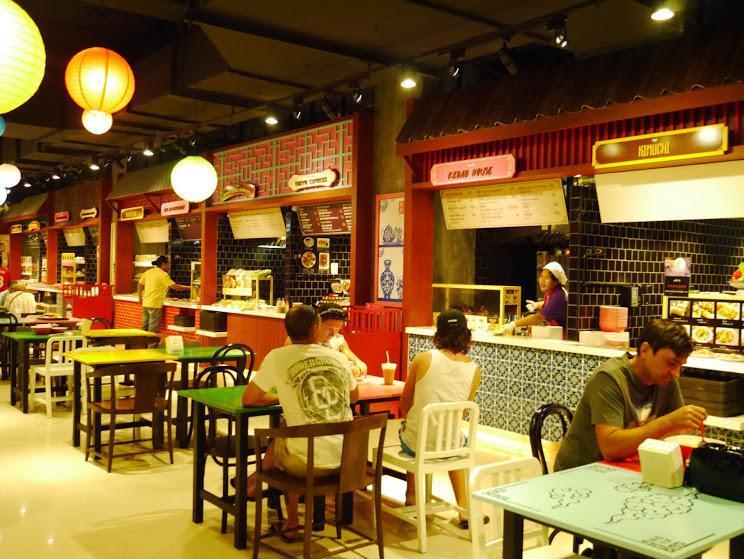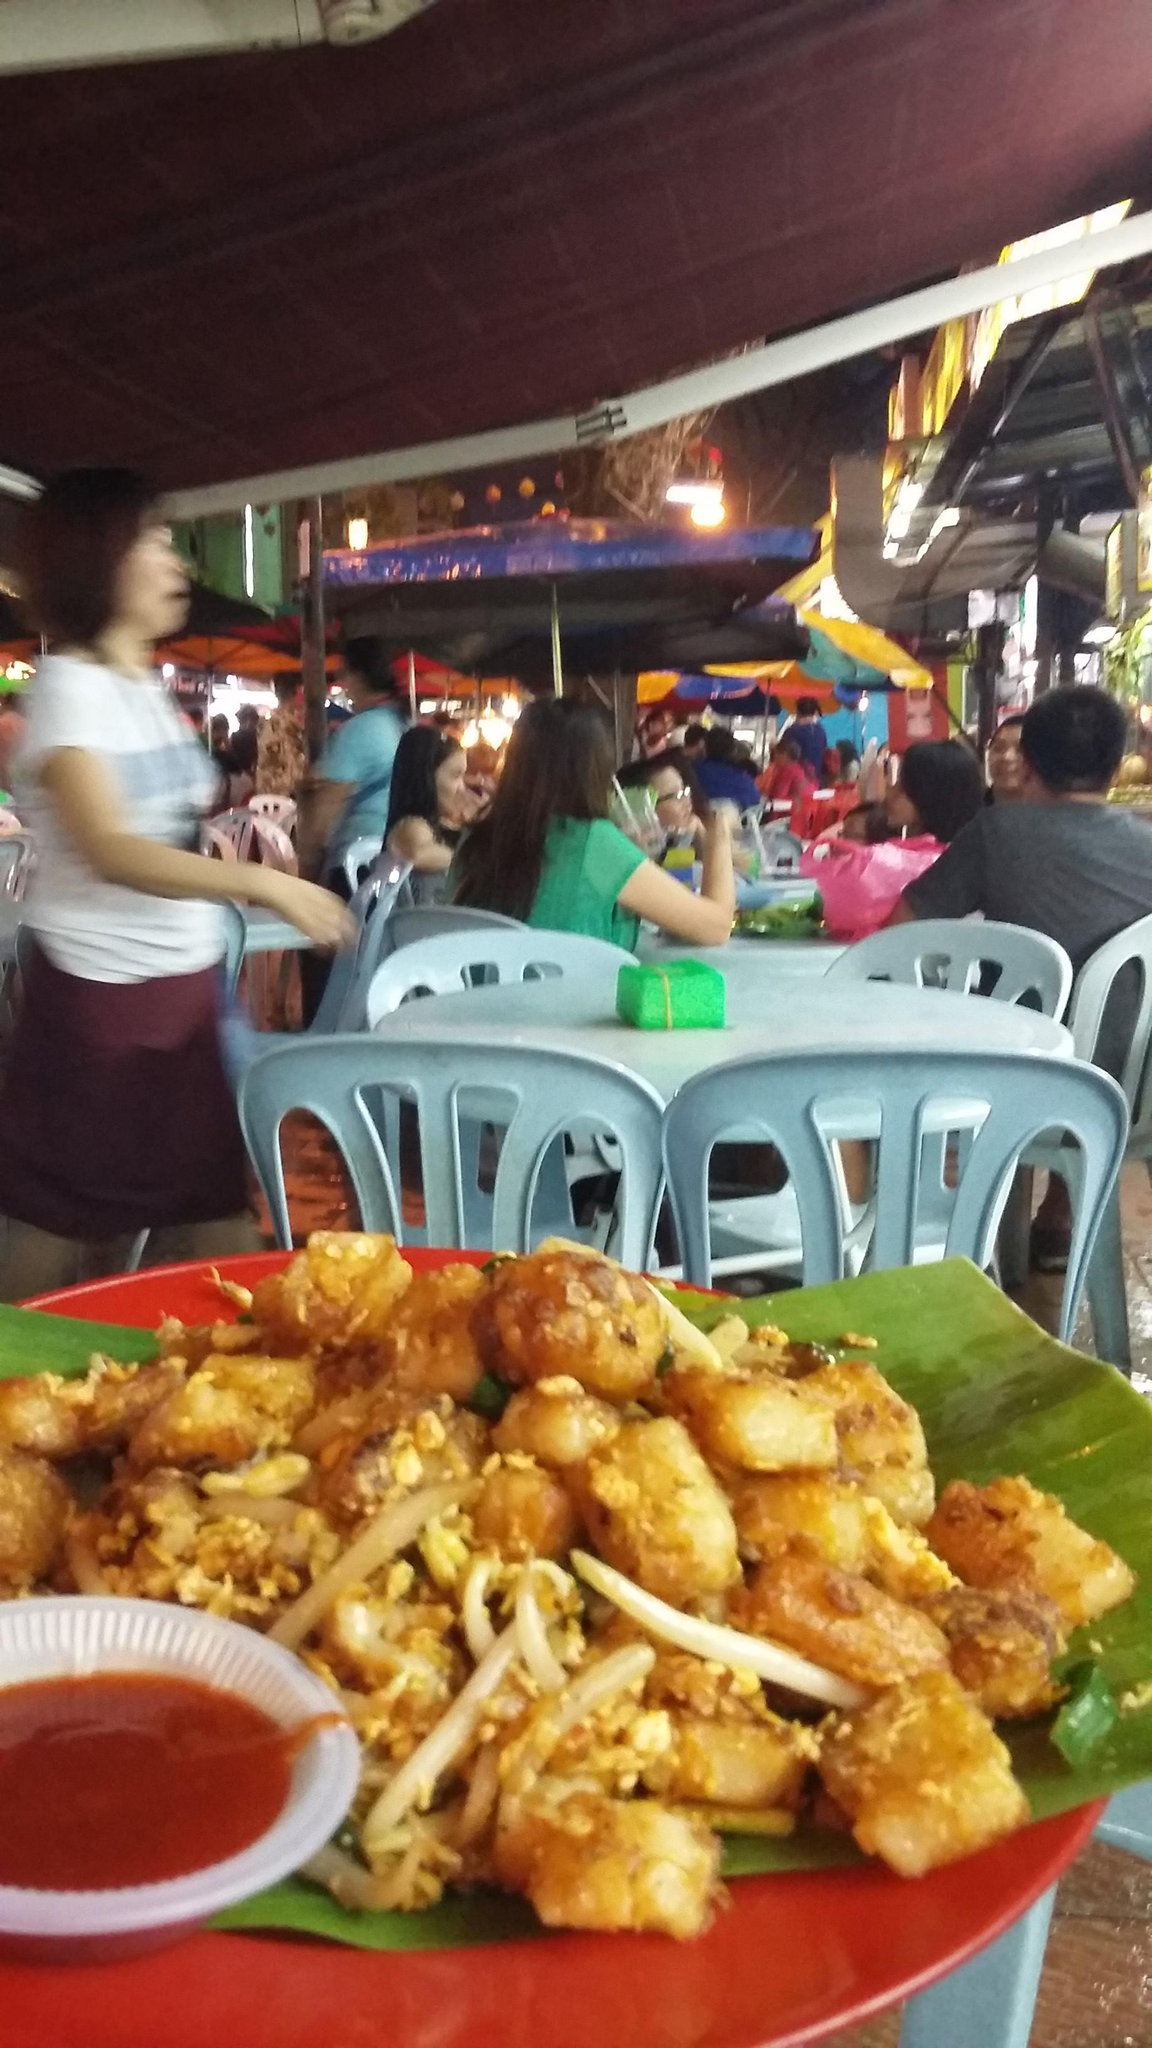The first image is the image on the left, the second image is the image on the right. For the images shown, is this caption "The foreground of an image features someone with an extended arm holding up multiple white plates filled with food." true? Answer yes or no. No. The first image is the image on the left, the second image is the image on the right. Considering the images on both sides, is "In at one image there is a server holding at least two white plates." valid? Answer yes or no. No. 